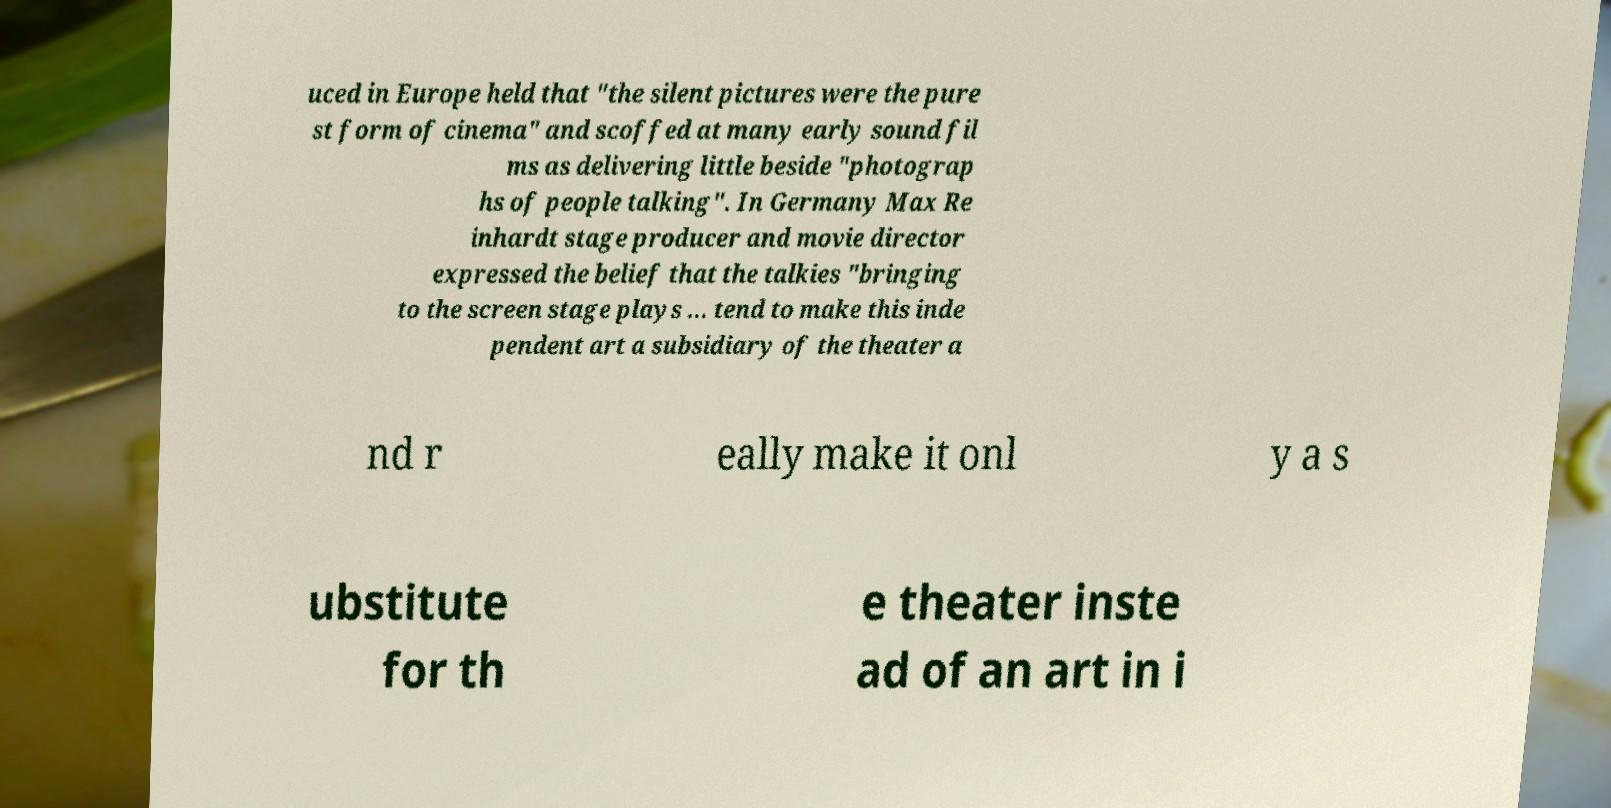Can you read and provide the text displayed in the image?This photo seems to have some interesting text. Can you extract and type it out for me? uced in Europe held that "the silent pictures were the pure st form of cinema" and scoffed at many early sound fil ms as delivering little beside "photograp hs of people talking". In Germany Max Re inhardt stage producer and movie director expressed the belief that the talkies "bringing to the screen stage plays ... tend to make this inde pendent art a subsidiary of the theater a nd r eally make it onl y a s ubstitute for th e theater inste ad of an art in i 